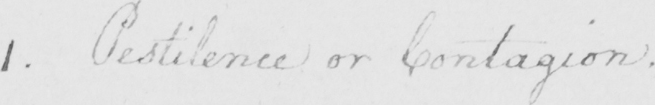What text is written in this handwritten line? 1 . Pestilence or Contagion . 